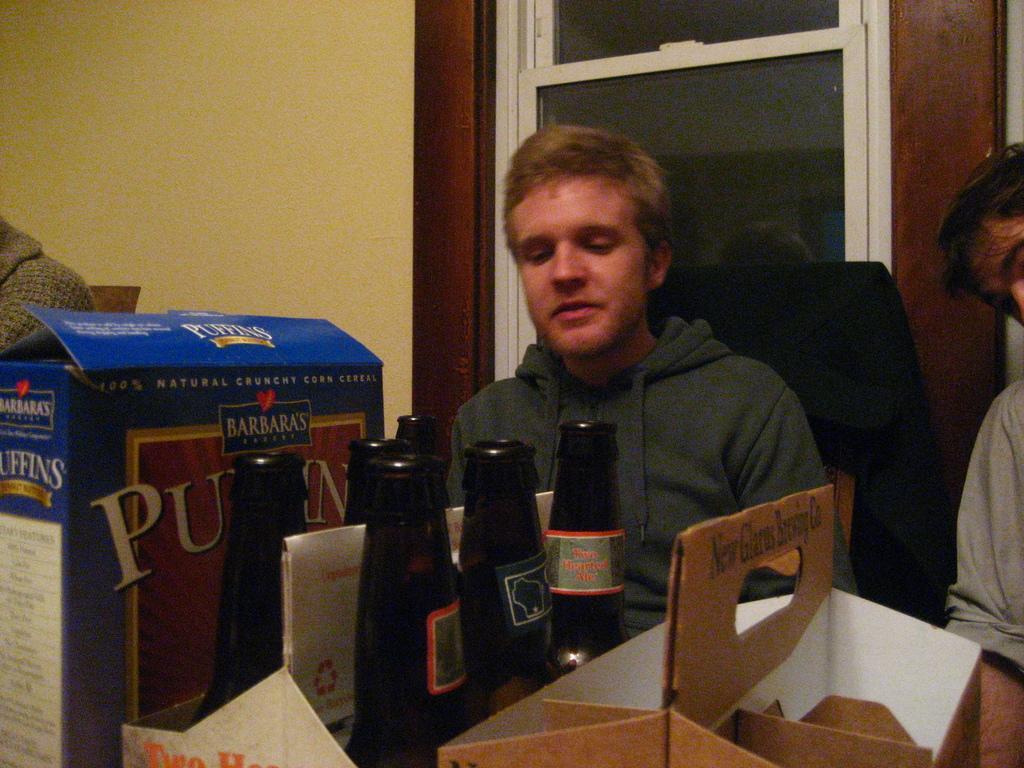Describe this image in one or two sentences. In this image I can see two people sitting in chairs. I can see some bottles and cartons in front of them. I can see a glass window behind them. I can see another person sitting in a chair on the left hand side of the image. 